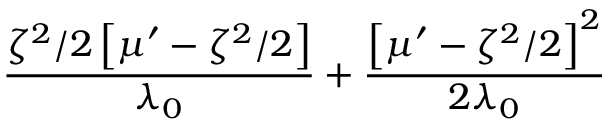<formula> <loc_0><loc_0><loc_500><loc_500>\frac { \zeta ^ { 2 } / 2 \left [ \mu ^ { \prime } - \zeta ^ { 2 } / 2 \right ] } { \lambda _ { 0 } } + \frac { \left [ \mu ^ { \prime } - \zeta ^ { 2 } / 2 \right ] ^ { 2 } } { 2 \lambda _ { 0 } }</formula> 